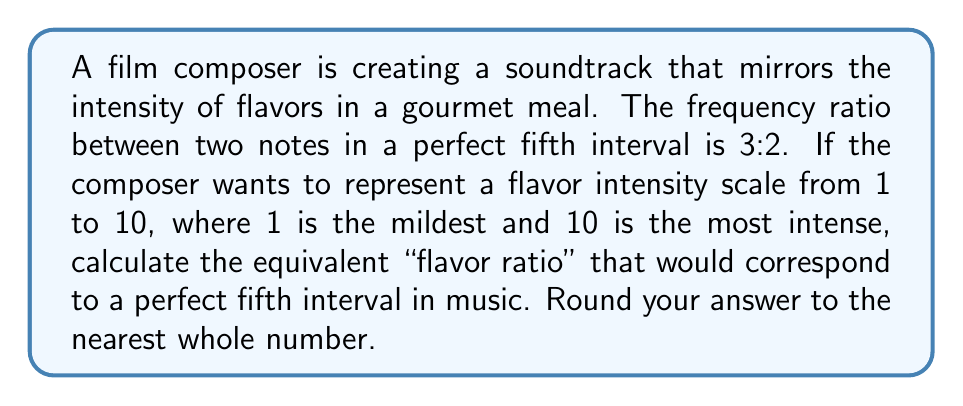Show me your answer to this math problem. Let's approach this step-by-step:

1) First, we need to understand the relationship between the musical interval and the flavor intensity scale:
   - The perfect fifth has a frequency ratio of 3:2
   - The flavor intensity scale ranges from 1 to 10

2) To find the equivalent ratio on the flavor scale, we can set up a proportion:
   $\frac{3}{2} = \frac{x}{1}$
   Where $x$ represents the higher intensity on the flavor scale, and 1 represents the mildest flavor.

3) Now, we can solve for $x$:
   $x = \frac{3}{2} \cdot 1 = 1.5$

4) This means that if 1 represents the mildest flavor, the corresponding intense flavor would be at 1.5 on the scale.

5) However, we need to adjust this to fit the 1-10 scale. We can do this by multiplying both values by a factor that brings the maximum close to 10:
   $1 \cdot 6.67 \approx 6.67$
   $1.5 \cdot 6.67 = 10$

6) Rounding 6.67 to the nearest whole number gives us 7.

Therefore, on the 1-10 flavor intensity scale, a perfect fifth interval would be represented by the ratio 7:10.
Answer: 7:10 